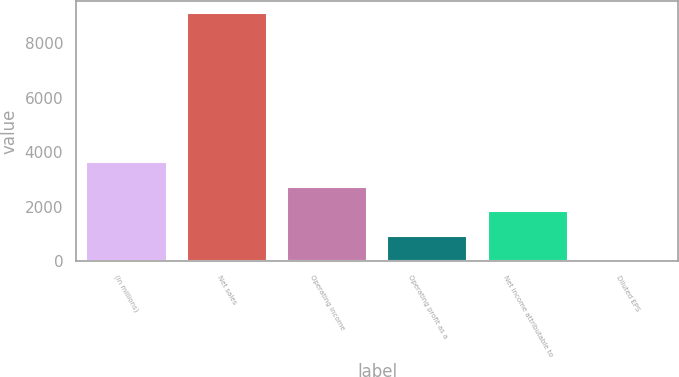Convert chart to OTSL. <chart><loc_0><loc_0><loc_500><loc_500><bar_chart><fcel>(in millions)<fcel>Net sales<fcel>Operating income<fcel>Operating profit as a<fcel>Net income attributable to<fcel>Diluted EPS<nl><fcel>3640.68<fcel>9101<fcel>2730.63<fcel>910.53<fcel>1820.58<fcel>0.48<nl></chart> 